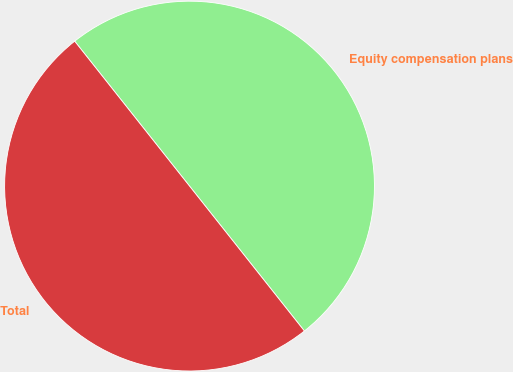Convert chart. <chart><loc_0><loc_0><loc_500><loc_500><pie_chart><fcel>Equity compensation plans<fcel>Total<nl><fcel>50.0%<fcel>50.0%<nl></chart> 